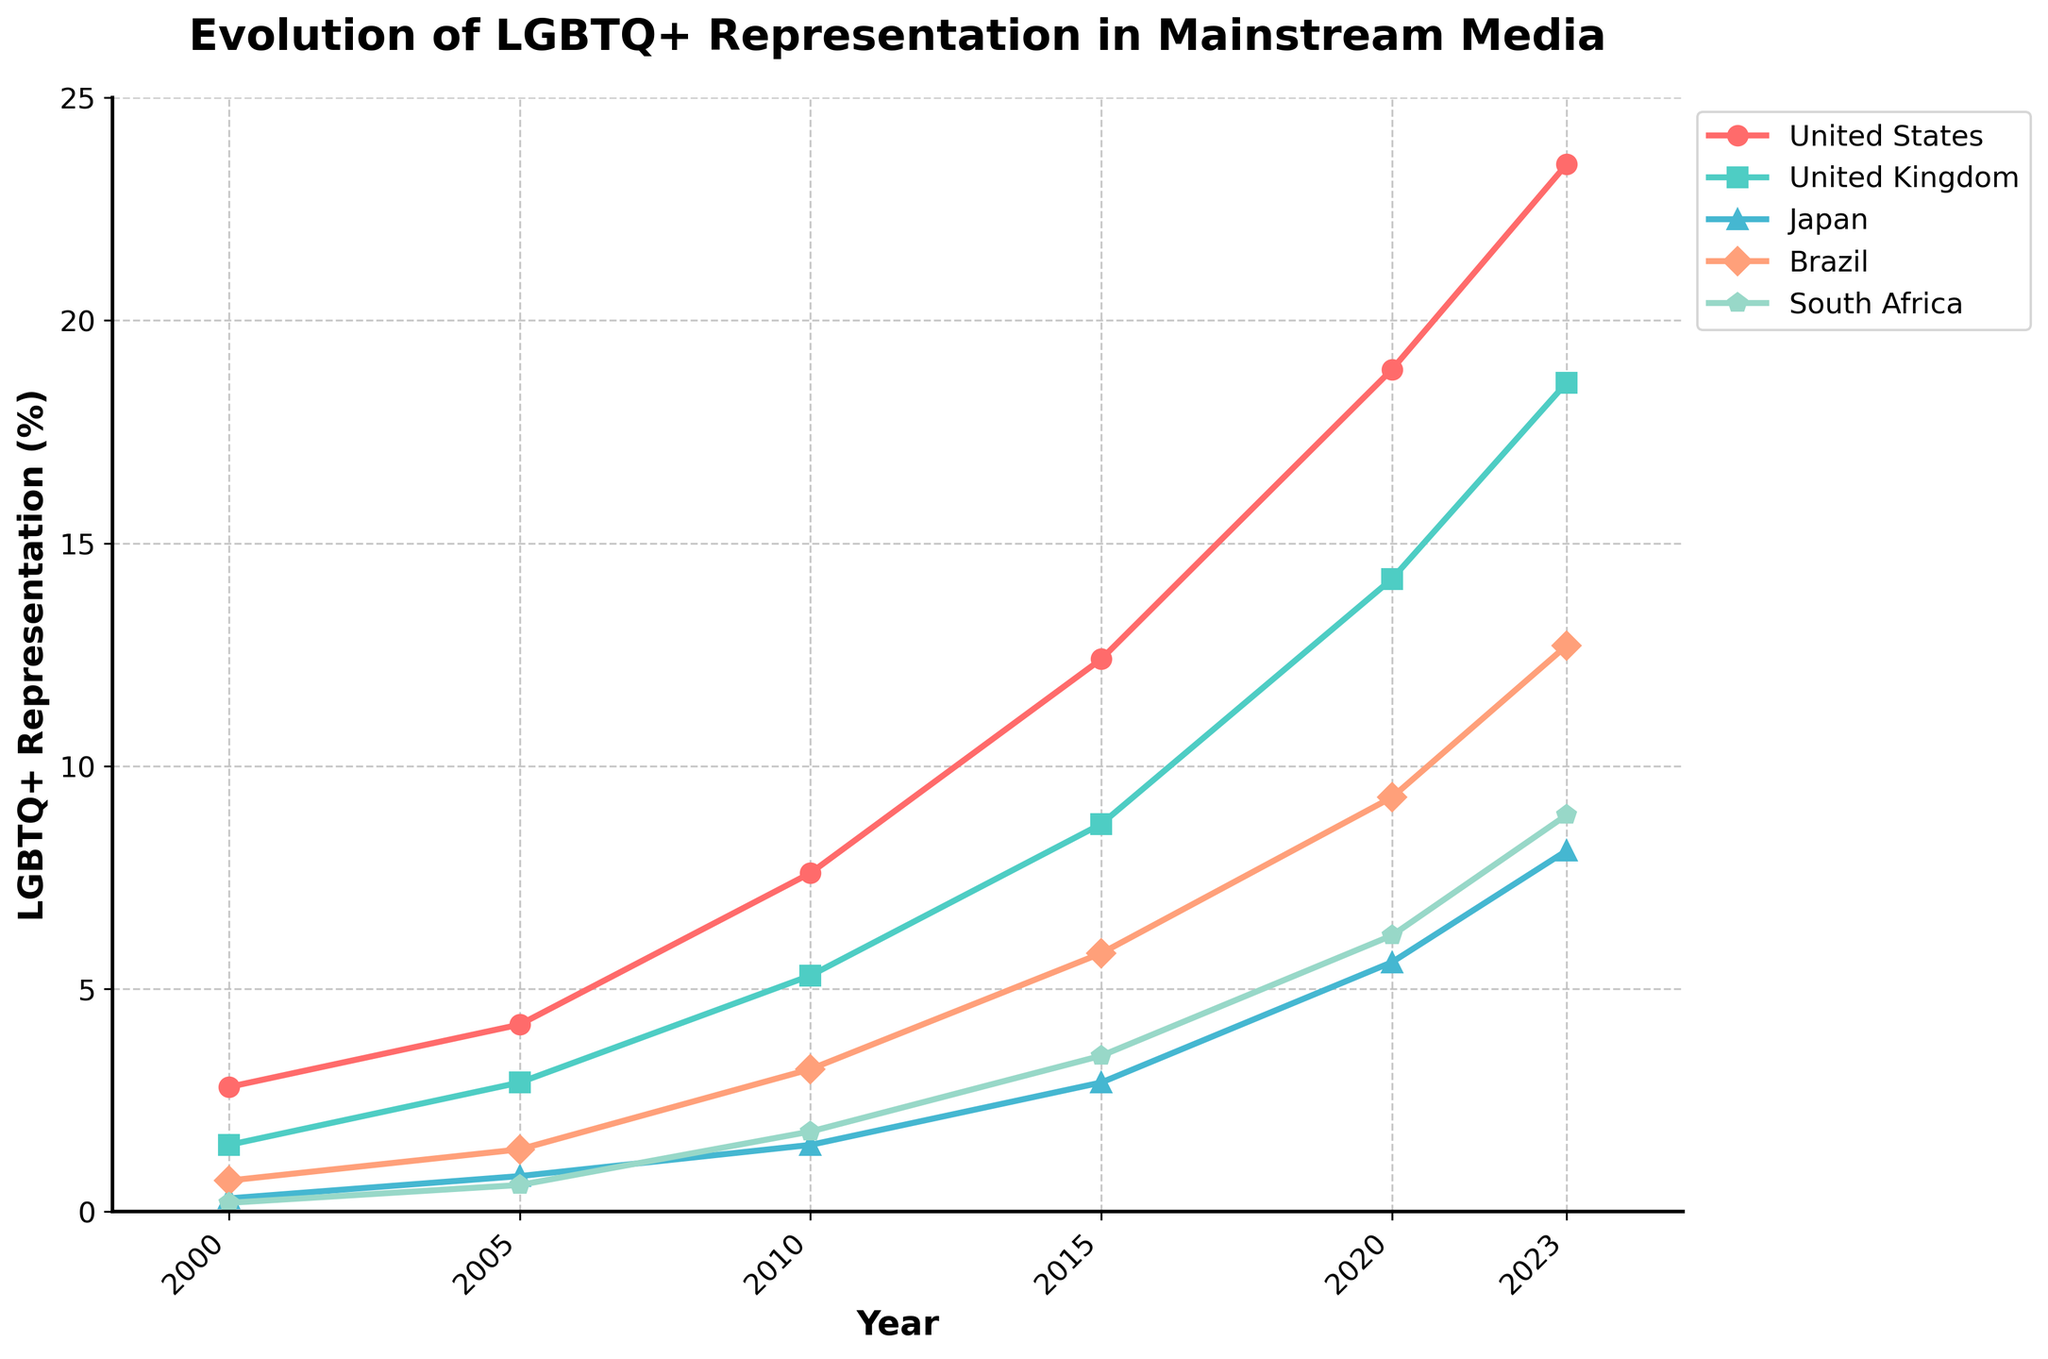What was the representation percentage in the United States in 2010? To find the representation percentage in the United States in 2010, locate the corresponding point on the line chart for the United States, which is marked with circles.
Answer: 7.6 Which country showed the highest LGBTQ+ representation in 2023? To determine which country had the highest LGBTQ+ representation in 2023, compare the heights of the lines at the 2023 marker. The highest point will show the country with the highest representation.
Answer: United States Was LGBTQ+ representation higher in Brazil or Japan in 2015? To compare the LGBTQ+ representation between Brazil and Japan in 2015, find the points for both countries in the corresponding year and compare their heights on the chart.
Answer: Brazil Calculate the increase in LGBTQ+ representation in South Africa from 2000 to 2023. To calculate the increase, subtract the representation percentage of South Africa in 2000 from that in 2023 (8.9 - 0.2).
Answer: 8.7 Which country had the steepest rise in LGBTQ+ representation between 2000 and 2023? To determine the steepest rise, compare the slopes of the lines for each country from 2000 to 2023. The line with the steepest upward angle will indicate the country with the most significant increase.
Answer: United States Is the percentage of LGBTQ+ representation in the United Kingdom higher or lower than in Japan in 2020? Locate the points for the United Kingdom and Japan in 2020 and compare their heights.
Answer: Higher How many countries had an LGBTQ+ representation percentage above 10% by 2023? Count the countries where the representation percentage in 2023 exceeds 10% by looking at the heights of the points for that year.
Answer: 3 What is the combined representation percentage for the United States and the United Kingdom in 2023? Add the representation percentages of the United States and the United Kingdom in 2023 (23.5 + 18.6).
Answer: 42.1 Compare the growth in LGBTQ+ representation in the United Kingdom and Brazil from 2005 to 2015. Which country experienced a greater increase? Calculate the increase for each country between these years: United Kingdom (8.7 - 2.9) and Brazil (5.8 - 1.4). Then compare the differences.
Answer: United Kingdom What's the average LGBTQ+ representation percentage in Japan across all the years provided? Sum all the representation percentages for Japan and divide by the number of years (0.3 + 0.8 + 1.5 + 2.9 + 5.6 + 8.1) / 6.
Answer: 3.2 